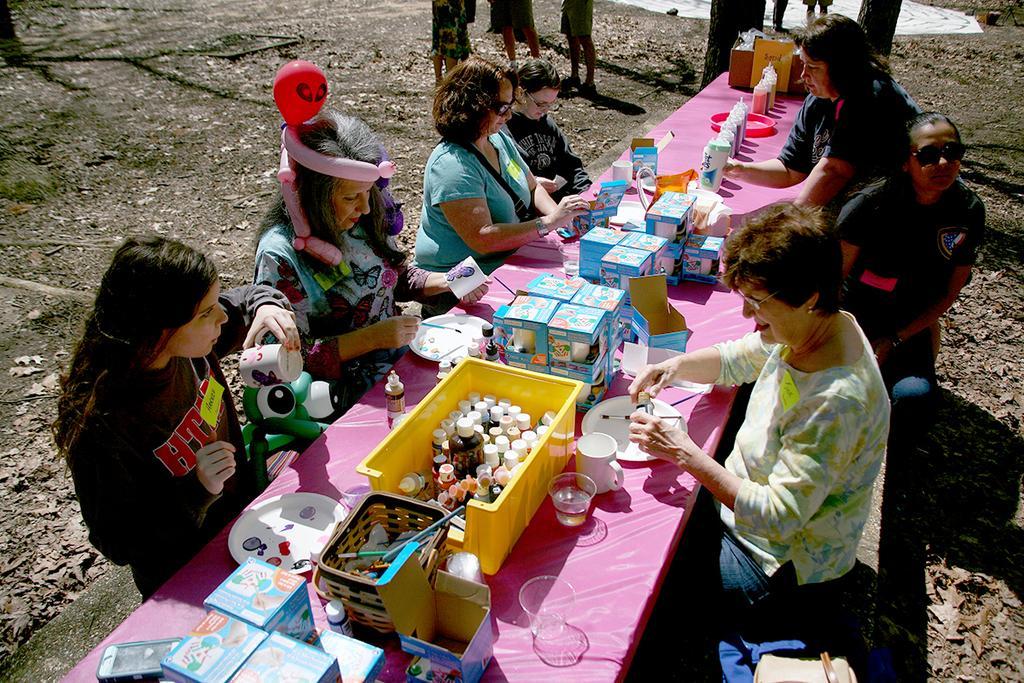Can you describe this image briefly? In this image we can see few persons are sitting on the platforms at the table and on the table we can see boxes, plates, glasses, cups, brush and other objects and a person is holding cup in the hand. In the background we can see few persons, leaves, trees and objects on the ground. 